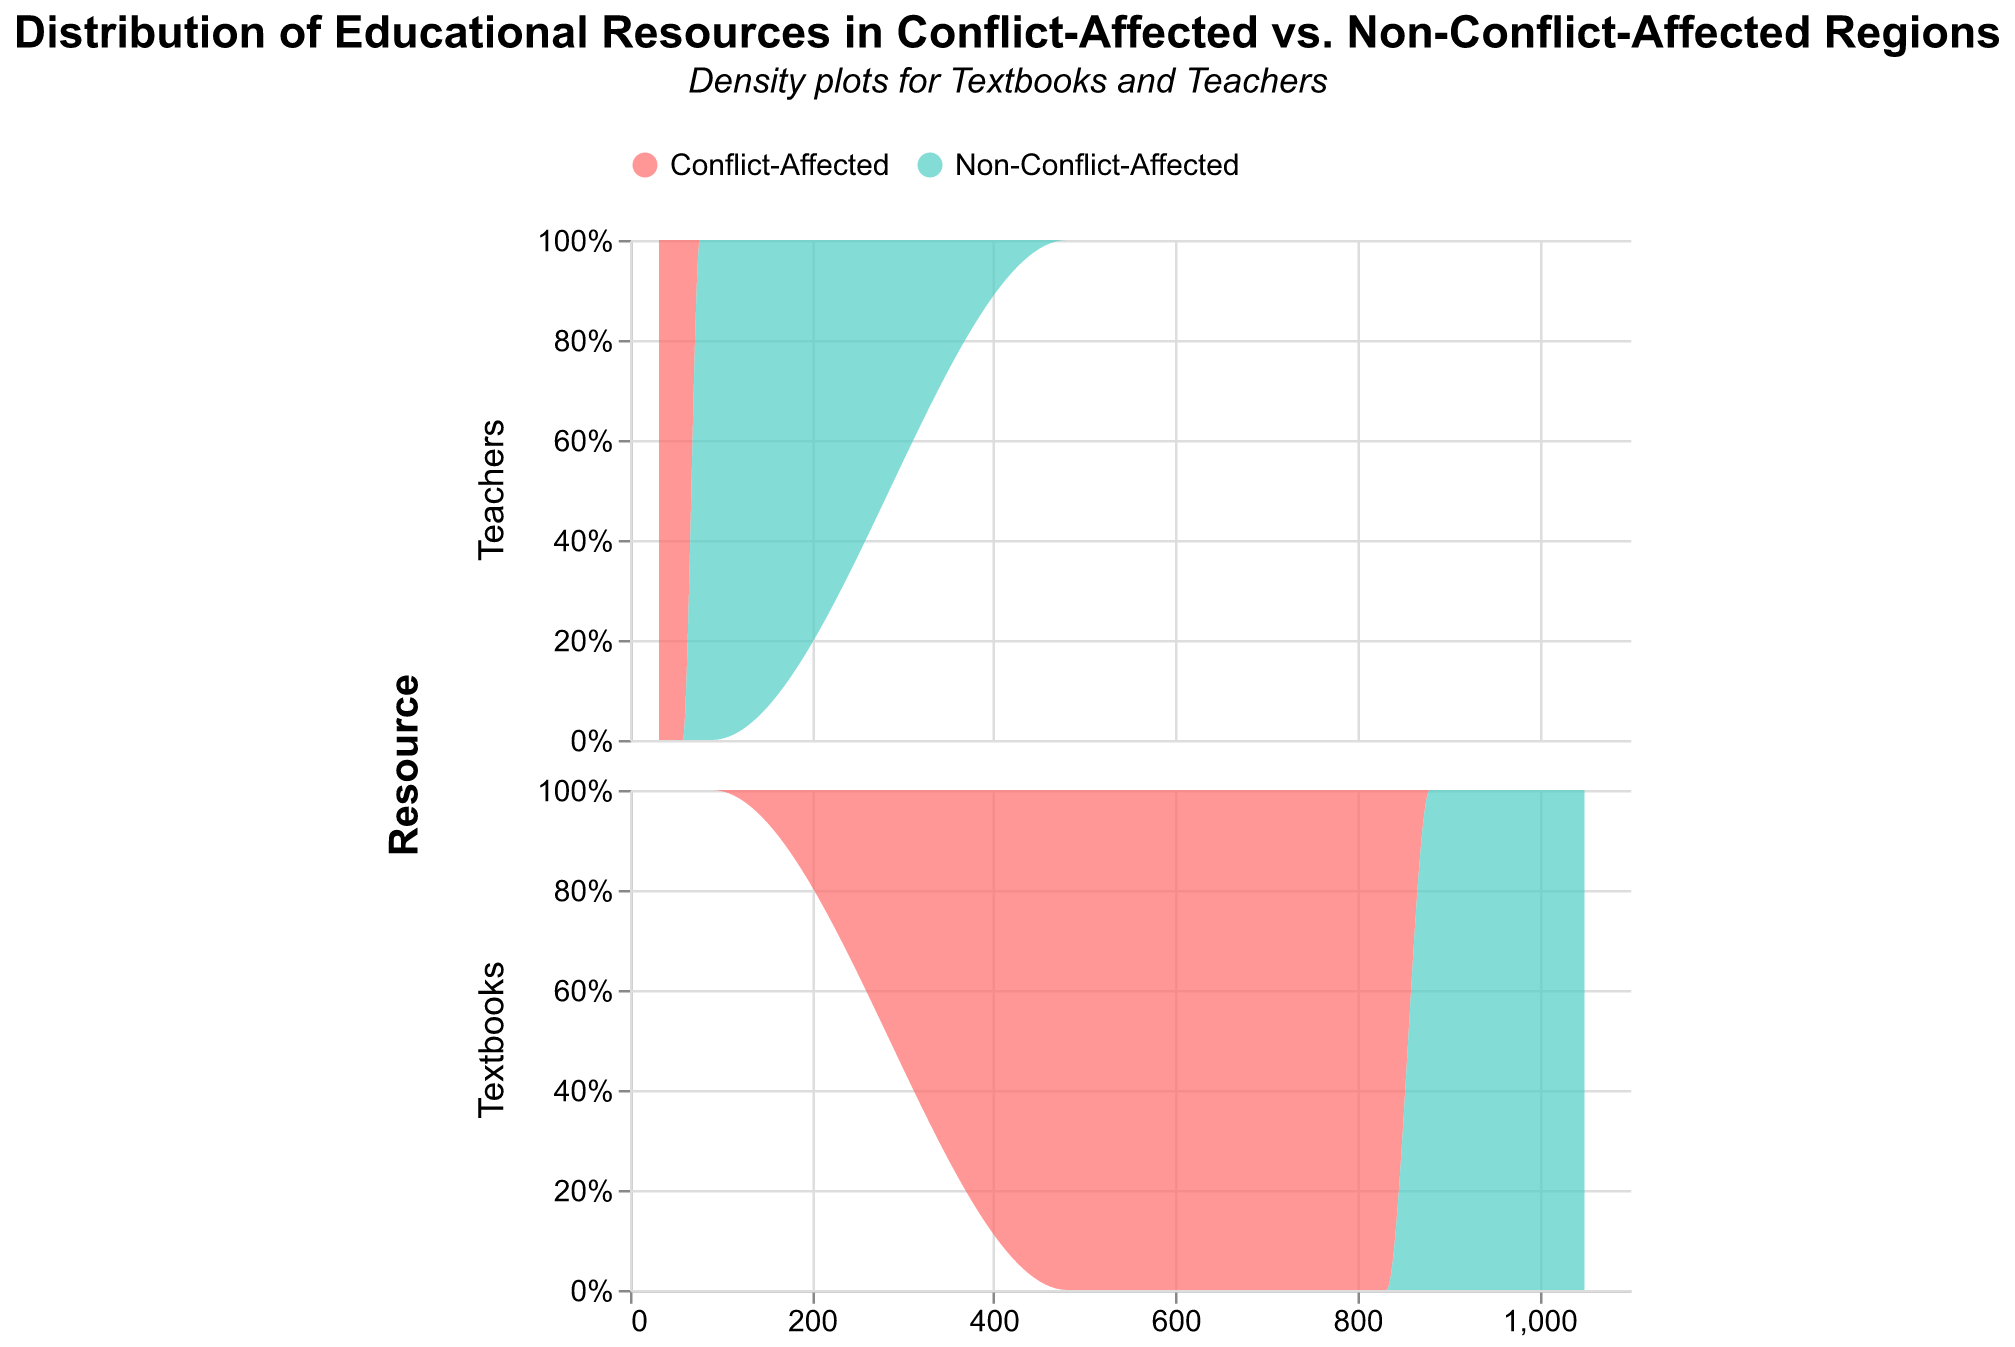What is the title of the figure? The title of the figure is usually displayed at the top and it directly indicates what the figure is about.
Answer: Distribution of Educational Resources in Conflict-Affected vs. Non-Conflict-Affected Regions What resource is shown in the first row of the subplot? The resource shown in the first row of the subplot is listed at the top of the left axis in the figure.
Answer: Textbooks Which region has a higher frequency of textbooks? The density plot will show a higher peak for the region with more textbooks.
Answer: Non-Conflict-Affected Looking at the distribution of teachers, which region appears to have the higher average value? A higher average value will be indicated by the peak of the density plot being positioned further to the right.
Answer: Non-Conflict-Affected Compare the spread of textbooks distribution between both regions. Which region has a wider spread? The distribution with a wider base will show a wider spread, indicating more variability in the number of textbooks.
Answer: Non-Conflict-Affected In the 'Teachers' subplot, where is the density peak higher, and what does it mean? The peak that is higher indicates a region where the number of teachers is more frequently at the dominant value.
Answer: Non-Conflict-Affected Looking at the 'Textbooks' subplot, what is the approximate range of values for Conflict-Affected regions? The range of values can be inferred from the x-axis values that cover the width of the density plot.
Answer: 481 to 832 Which subplot shows a more significant disparity between Conflict-Affected and Non-Conflict-Affected regions? The subplot with more separation between the density plots of the two regions indicates greater disparity.
Answer: Textbooks How does the relative frequency of teachers in Conflict-Affected regions compare to that in Non-Conflict-Affected regions? The relative frequency can be assessed by the height of the density plots; higher peaks indicate higher frequencies.
Answer: Lower in Conflict-Affected regions What might be a reason for the disparity in the distribution of textbooks and teachers between the two regions shown in the figure? The explanation requires interpreting the visual data and considering potential underlying causes such as infrastructure, safety, and available funding in conflict vs. non-conflict-affected regions.
Answer: Conflict impacts resource allocation 